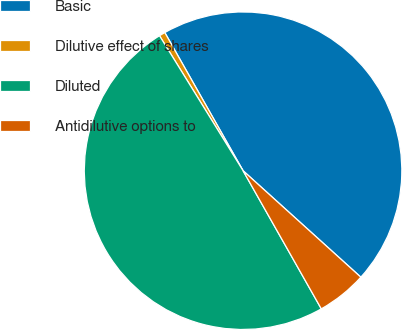<chart> <loc_0><loc_0><loc_500><loc_500><pie_chart><fcel>Basic<fcel>Dilutive effect of shares<fcel>Diluted<fcel>Antidilutive options to<nl><fcel>44.9%<fcel>0.62%<fcel>49.38%<fcel>5.1%<nl></chart> 